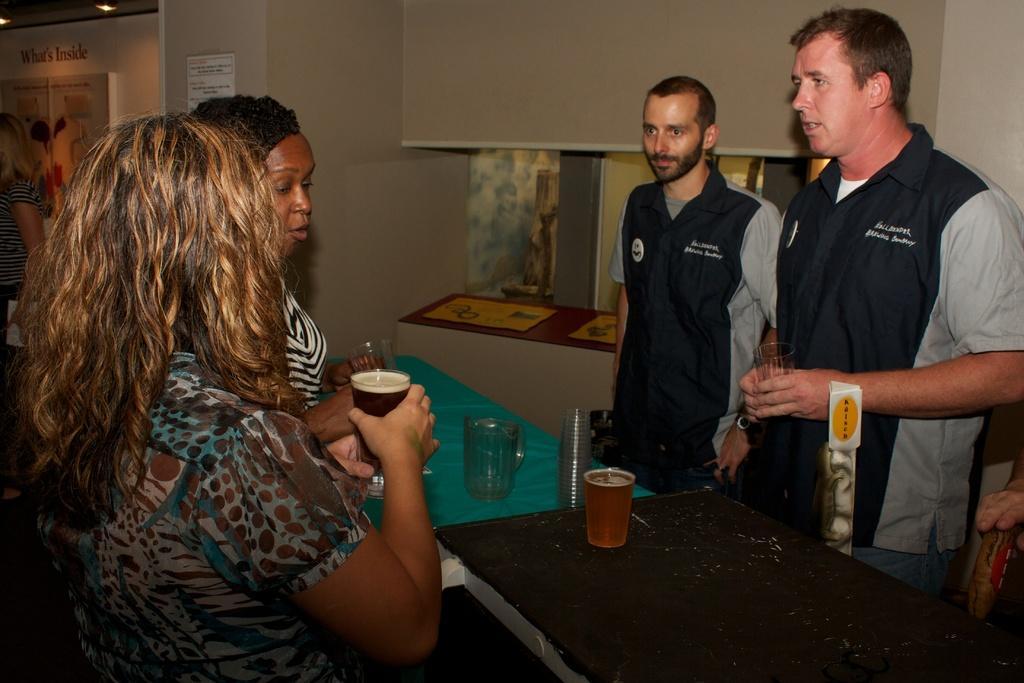How would you summarize this image in a sentence or two? 4 people are standing and talking to each other. they are holding glass in their hands. on the table there are jug and glasses. 